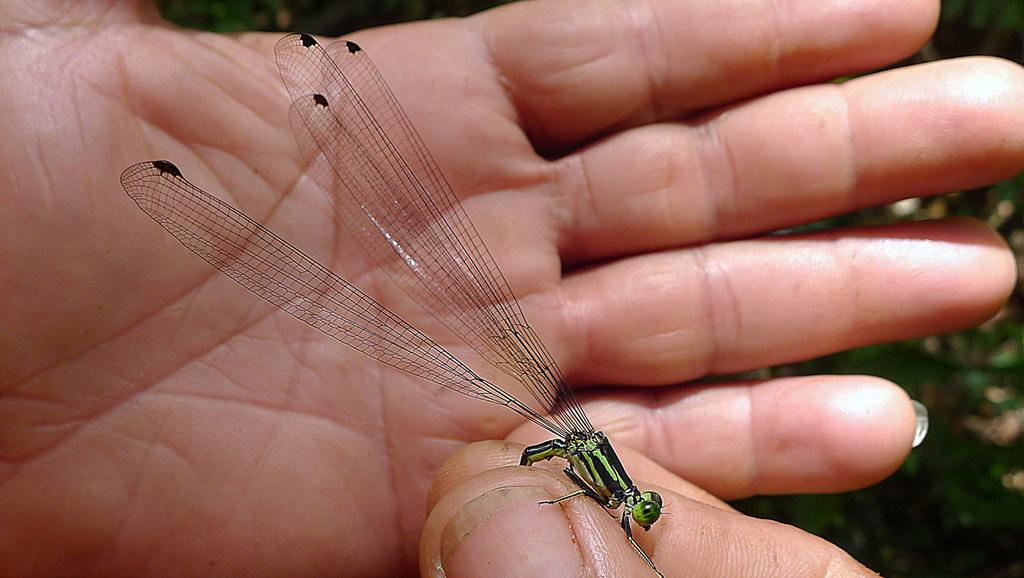What type of insect is in the image? There is a small grasshopper in the image. Where is the grasshopper located? The grasshopper is in a person's palm. What type of offer is being made by the tree in the image? There is no tree present in the image, and therefore no offer can be made by a tree. 